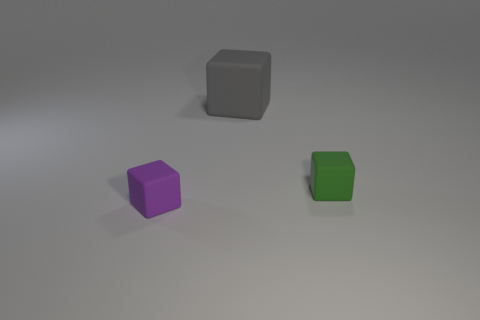Can you describe the lighting in this scene? The scene is illuminated by a soft, diffused light source that creates gentle shadows on the ground, suggesting an overcast sky or an indoor setting with ambient lighting. 